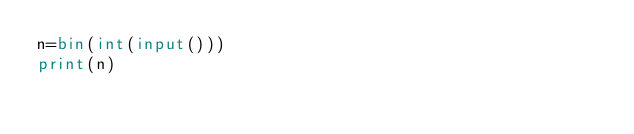Convert code to text. <code><loc_0><loc_0><loc_500><loc_500><_Python_>n=bin(int(input()))
print(n)
</code> 